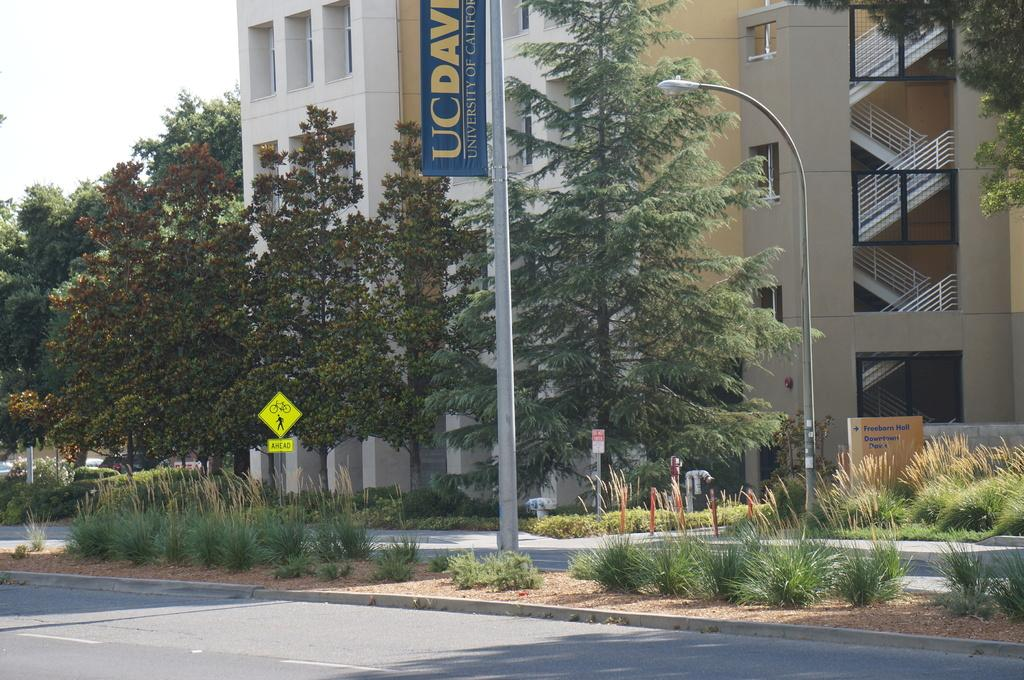What type of structure is visible in the image? There is a building in the image. What is in front of the building? There are trees in front of the building. What type of lighting is present in the image? Lamp posts are present in the image. What type of vegetation can be seen in the image? Plants are visible in the image. What type of signage is present in the image? Sign boards are in the image. What type of infrastructure is present in the image? Water pipes are in the image. What type of transportation surface is present in the image? Roads are present in the image. How many beams can be seen supporting the sidewalk in the image? There is no sidewalk present in the image, and therefore no beams supporting it. 